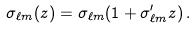<formula> <loc_0><loc_0><loc_500><loc_500>\sigma _ { \ell m } ( z ) = \sigma _ { \ell m } ( 1 + \sigma _ { \ell m } ^ { \prime } z ) \, .</formula> 